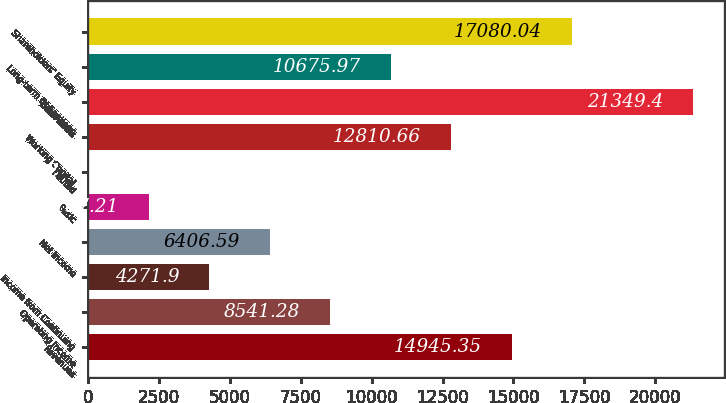Convert chart. <chart><loc_0><loc_0><loc_500><loc_500><bar_chart><fcel>Revenues<fcel>Operating Income<fcel>Income from Continuing<fcel>Net Income<fcel>Basic<fcel>Diluted<fcel>Working Capital<fcel>Total Assets<fcel>Long-term Obligations<fcel>Shareholders' Equity<nl><fcel>14945.4<fcel>8541.28<fcel>4271.9<fcel>6406.59<fcel>2137.21<fcel>2.52<fcel>12810.7<fcel>21349.4<fcel>10676<fcel>17080<nl></chart> 